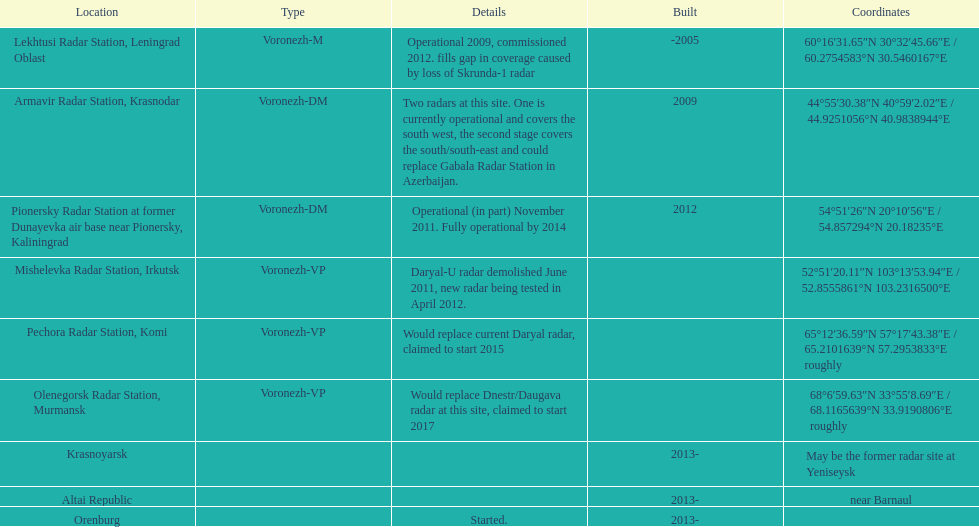How long did it take the pionersky radar station to go from partially operational to fully operational? 3 years. 